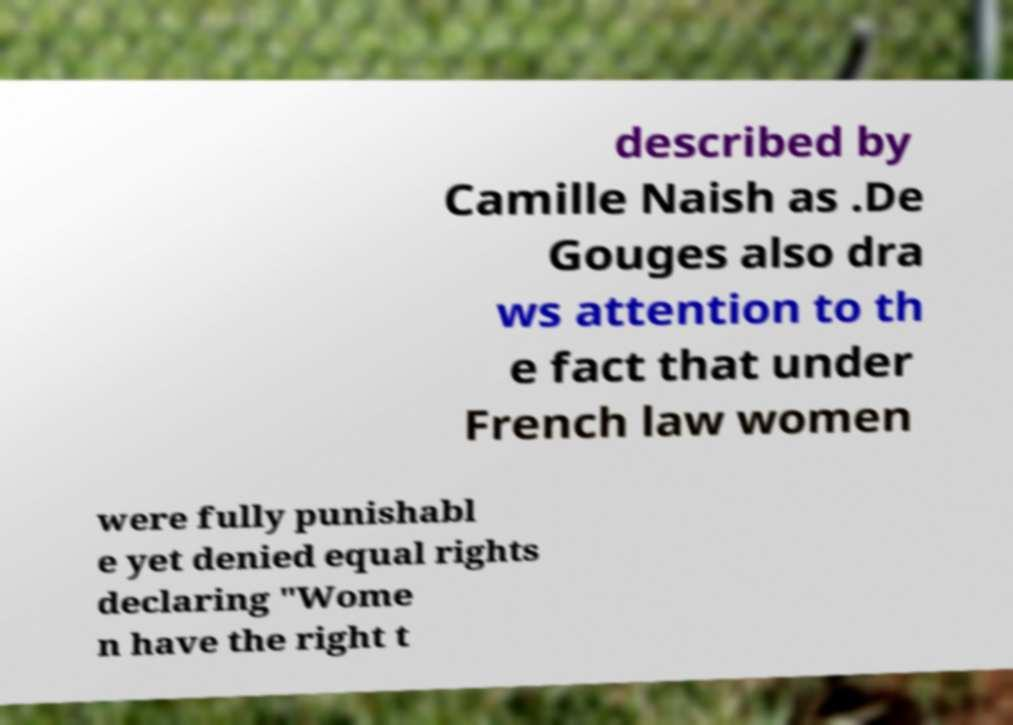Please read and relay the text visible in this image. What does it say? described by Camille Naish as .De Gouges also dra ws attention to th e fact that under French law women were fully punishabl e yet denied equal rights declaring "Wome n have the right t 